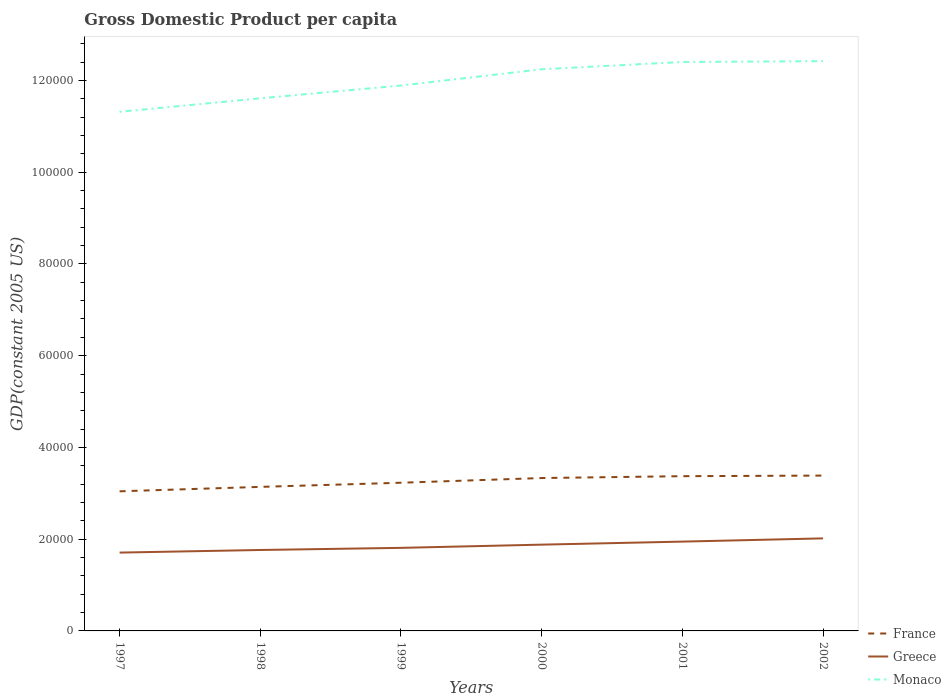How many different coloured lines are there?
Keep it short and to the point. 3. Is the number of lines equal to the number of legend labels?
Provide a succinct answer. Yes. Across all years, what is the maximum GDP per capita in Monaco?
Your response must be concise. 1.13e+05. What is the total GDP per capita in Greece in the graph?
Offer a very short reply. -1825.32. What is the difference between the highest and the second highest GDP per capita in Greece?
Provide a succinct answer. 3099.75. What is the difference between the highest and the lowest GDP per capita in Monaco?
Offer a terse response. 3. Is the GDP per capita in Monaco strictly greater than the GDP per capita in France over the years?
Give a very brief answer. No. How many lines are there?
Provide a succinct answer. 3. How many years are there in the graph?
Give a very brief answer. 6. What is the difference between two consecutive major ticks on the Y-axis?
Provide a short and direct response. 2.00e+04. Does the graph contain any zero values?
Keep it short and to the point. No. Where does the legend appear in the graph?
Provide a short and direct response. Bottom right. What is the title of the graph?
Provide a short and direct response. Gross Domestic Product per capita. What is the label or title of the X-axis?
Offer a very short reply. Years. What is the label or title of the Y-axis?
Your answer should be very brief. GDP(constant 2005 US). What is the GDP(constant 2005 US) in France in 1997?
Provide a succinct answer. 3.04e+04. What is the GDP(constant 2005 US) of Greece in 1997?
Your answer should be very brief. 1.71e+04. What is the GDP(constant 2005 US) of Monaco in 1997?
Your answer should be compact. 1.13e+05. What is the GDP(constant 2005 US) in France in 1998?
Provide a short and direct response. 3.14e+04. What is the GDP(constant 2005 US) of Greece in 1998?
Your answer should be very brief. 1.76e+04. What is the GDP(constant 2005 US) in Monaco in 1998?
Offer a very short reply. 1.16e+05. What is the GDP(constant 2005 US) of France in 1999?
Offer a very short reply. 3.23e+04. What is the GDP(constant 2005 US) of Greece in 1999?
Keep it short and to the point. 1.81e+04. What is the GDP(constant 2005 US) of Monaco in 1999?
Ensure brevity in your answer.  1.19e+05. What is the GDP(constant 2005 US) of France in 2000?
Provide a succinct answer. 3.33e+04. What is the GDP(constant 2005 US) in Greece in 2000?
Ensure brevity in your answer.  1.88e+04. What is the GDP(constant 2005 US) in Monaco in 2000?
Ensure brevity in your answer.  1.22e+05. What is the GDP(constant 2005 US) of France in 2001?
Provide a short and direct response. 3.37e+04. What is the GDP(constant 2005 US) of Greece in 2001?
Offer a very short reply. 1.95e+04. What is the GDP(constant 2005 US) in Monaco in 2001?
Your answer should be very brief. 1.24e+05. What is the GDP(constant 2005 US) of France in 2002?
Your answer should be compact. 3.39e+04. What is the GDP(constant 2005 US) of Greece in 2002?
Keep it short and to the point. 2.02e+04. What is the GDP(constant 2005 US) of Monaco in 2002?
Give a very brief answer. 1.24e+05. Across all years, what is the maximum GDP(constant 2005 US) in France?
Keep it short and to the point. 3.39e+04. Across all years, what is the maximum GDP(constant 2005 US) of Greece?
Offer a terse response. 2.02e+04. Across all years, what is the maximum GDP(constant 2005 US) in Monaco?
Your answer should be very brief. 1.24e+05. Across all years, what is the minimum GDP(constant 2005 US) of France?
Keep it short and to the point. 3.04e+04. Across all years, what is the minimum GDP(constant 2005 US) in Greece?
Offer a very short reply. 1.71e+04. Across all years, what is the minimum GDP(constant 2005 US) of Monaco?
Ensure brevity in your answer.  1.13e+05. What is the total GDP(constant 2005 US) in France in the graph?
Make the answer very short. 1.95e+05. What is the total GDP(constant 2005 US) in Greece in the graph?
Keep it short and to the point. 1.11e+05. What is the total GDP(constant 2005 US) in Monaco in the graph?
Provide a succinct answer. 7.19e+05. What is the difference between the GDP(constant 2005 US) in France in 1997 and that in 1998?
Give a very brief answer. -966.34. What is the difference between the GDP(constant 2005 US) of Greece in 1997 and that in 1998?
Your answer should be very brief. -569.5. What is the difference between the GDP(constant 2005 US) of Monaco in 1997 and that in 1998?
Provide a short and direct response. -2942.47. What is the difference between the GDP(constant 2005 US) in France in 1997 and that in 1999?
Your answer should be compact. -1869.59. What is the difference between the GDP(constant 2005 US) of Greece in 1997 and that in 1999?
Provide a short and direct response. -1031.95. What is the difference between the GDP(constant 2005 US) in Monaco in 1997 and that in 1999?
Your response must be concise. -5725.95. What is the difference between the GDP(constant 2005 US) in France in 1997 and that in 2000?
Offer a very short reply. -2892.38. What is the difference between the GDP(constant 2005 US) in Greece in 1997 and that in 2000?
Give a very brief answer. -1733.08. What is the difference between the GDP(constant 2005 US) in Monaco in 1997 and that in 2000?
Ensure brevity in your answer.  -9273.51. What is the difference between the GDP(constant 2005 US) of France in 1997 and that in 2001?
Your answer should be very brief. -3297.35. What is the difference between the GDP(constant 2005 US) of Greece in 1997 and that in 2001?
Your answer should be very brief. -2394.82. What is the difference between the GDP(constant 2005 US) in Monaco in 1997 and that in 2001?
Your response must be concise. -1.09e+04. What is the difference between the GDP(constant 2005 US) of France in 1997 and that in 2002?
Give a very brief answer. -3427.48. What is the difference between the GDP(constant 2005 US) of Greece in 1997 and that in 2002?
Keep it short and to the point. -3099.75. What is the difference between the GDP(constant 2005 US) in Monaco in 1997 and that in 2002?
Provide a succinct answer. -1.10e+04. What is the difference between the GDP(constant 2005 US) of France in 1998 and that in 1999?
Keep it short and to the point. -903.25. What is the difference between the GDP(constant 2005 US) in Greece in 1998 and that in 1999?
Provide a succinct answer. -462.45. What is the difference between the GDP(constant 2005 US) in Monaco in 1998 and that in 1999?
Your answer should be very brief. -2783.48. What is the difference between the GDP(constant 2005 US) in France in 1998 and that in 2000?
Give a very brief answer. -1926.04. What is the difference between the GDP(constant 2005 US) in Greece in 1998 and that in 2000?
Provide a short and direct response. -1163.58. What is the difference between the GDP(constant 2005 US) of Monaco in 1998 and that in 2000?
Provide a succinct answer. -6331.05. What is the difference between the GDP(constant 2005 US) in France in 1998 and that in 2001?
Offer a very short reply. -2331.01. What is the difference between the GDP(constant 2005 US) of Greece in 1998 and that in 2001?
Provide a succinct answer. -1825.32. What is the difference between the GDP(constant 2005 US) of Monaco in 1998 and that in 2001?
Give a very brief answer. -7915.61. What is the difference between the GDP(constant 2005 US) of France in 1998 and that in 2002?
Provide a short and direct response. -2461.14. What is the difference between the GDP(constant 2005 US) of Greece in 1998 and that in 2002?
Your answer should be very brief. -2530.25. What is the difference between the GDP(constant 2005 US) in Monaco in 1998 and that in 2002?
Provide a succinct answer. -8098.77. What is the difference between the GDP(constant 2005 US) in France in 1999 and that in 2000?
Give a very brief answer. -1022.79. What is the difference between the GDP(constant 2005 US) in Greece in 1999 and that in 2000?
Keep it short and to the point. -701.13. What is the difference between the GDP(constant 2005 US) in Monaco in 1999 and that in 2000?
Your answer should be compact. -3547.56. What is the difference between the GDP(constant 2005 US) in France in 1999 and that in 2001?
Offer a terse response. -1427.76. What is the difference between the GDP(constant 2005 US) in Greece in 1999 and that in 2001?
Offer a terse response. -1362.88. What is the difference between the GDP(constant 2005 US) of Monaco in 1999 and that in 2001?
Give a very brief answer. -5132.13. What is the difference between the GDP(constant 2005 US) of France in 1999 and that in 2002?
Provide a short and direct response. -1557.89. What is the difference between the GDP(constant 2005 US) of Greece in 1999 and that in 2002?
Keep it short and to the point. -2067.8. What is the difference between the GDP(constant 2005 US) of Monaco in 1999 and that in 2002?
Provide a succinct answer. -5315.29. What is the difference between the GDP(constant 2005 US) in France in 2000 and that in 2001?
Give a very brief answer. -404.97. What is the difference between the GDP(constant 2005 US) of Greece in 2000 and that in 2001?
Your answer should be very brief. -661.74. What is the difference between the GDP(constant 2005 US) in Monaco in 2000 and that in 2001?
Provide a succinct answer. -1584.56. What is the difference between the GDP(constant 2005 US) of France in 2000 and that in 2002?
Keep it short and to the point. -535.09. What is the difference between the GDP(constant 2005 US) of Greece in 2000 and that in 2002?
Make the answer very short. -1366.67. What is the difference between the GDP(constant 2005 US) in Monaco in 2000 and that in 2002?
Provide a succinct answer. -1767.72. What is the difference between the GDP(constant 2005 US) in France in 2001 and that in 2002?
Provide a short and direct response. -130.13. What is the difference between the GDP(constant 2005 US) in Greece in 2001 and that in 2002?
Keep it short and to the point. -704.93. What is the difference between the GDP(constant 2005 US) in Monaco in 2001 and that in 2002?
Your answer should be compact. -183.16. What is the difference between the GDP(constant 2005 US) of France in 1997 and the GDP(constant 2005 US) of Greece in 1998?
Make the answer very short. 1.28e+04. What is the difference between the GDP(constant 2005 US) in France in 1997 and the GDP(constant 2005 US) in Monaco in 1998?
Offer a terse response. -8.57e+04. What is the difference between the GDP(constant 2005 US) of Greece in 1997 and the GDP(constant 2005 US) of Monaco in 1998?
Give a very brief answer. -9.90e+04. What is the difference between the GDP(constant 2005 US) in France in 1997 and the GDP(constant 2005 US) in Greece in 1999?
Provide a succinct answer. 1.23e+04. What is the difference between the GDP(constant 2005 US) of France in 1997 and the GDP(constant 2005 US) of Monaco in 1999?
Your answer should be very brief. -8.85e+04. What is the difference between the GDP(constant 2005 US) of Greece in 1997 and the GDP(constant 2005 US) of Monaco in 1999?
Keep it short and to the point. -1.02e+05. What is the difference between the GDP(constant 2005 US) in France in 1997 and the GDP(constant 2005 US) in Greece in 2000?
Your answer should be compact. 1.16e+04. What is the difference between the GDP(constant 2005 US) of France in 1997 and the GDP(constant 2005 US) of Monaco in 2000?
Make the answer very short. -9.20e+04. What is the difference between the GDP(constant 2005 US) of Greece in 1997 and the GDP(constant 2005 US) of Monaco in 2000?
Your response must be concise. -1.05e+05. What is the difference between the GDP(constant 2005 US) of France in 1997 and the GDP(constant 2005 US) of Greece in 2001?
Offer a terse response. 1.10e+04. What is the difference between the GDP(constant 2005 US) in France in 1997 and the GDP(constant 2005 US) in Monaco in 2001?
Provide a short and direct response. -9.36e+04. What is the difference between the GDP(constant 2005 US) of Greece in 1997 and the GDP(constant 2005 US) of Monaco in 2001?
Ensure brevity in your answer.  -1.07e+05. What is the difference between the GDP(constant 2005 US) of France in 1997 and the GDP(constant 2005 US) of Greece in 2002?
Provide a succinct answer. 1.03e+04. What is the difference between the GDP(constant 2005 US) of France in 1997 and the GDP(constant 2005 US) of Monaco in 2002?
Provide a short and direct response. -9.38e+04. What is the difference between the GDP(constant 2005 US) in Greece in 1997 and the GDP(constant 2005 US) in Monaco in 2002?
Provide a short and direct response. -1.07e+05. What is the difference between the GDP(constant 2005 US) of France in 1998 and the GDP(constant 2005 US) of Greece in 1999?
Keep it short and to the point. 1.33e+04. What is the difference between the GDP(constant 2005 US) of France in 1998 and the GDP(constant 2005 US) of Monaco in 1999?
Make the answer very short. -8.75e+04. What is the difference between the GDP(constant 2005 US) in Greece in 1998 and the GDP(constant 2005 US) in Monaco in 1999?
Make the answer very short. -1.01e+05. What is the difference between the GDP(constant 2005 US) in France in 1998 and the GDP(constant 2005 US) in Greece in 2000?
Provide a succinct answer. 1.26e+04. What is the difference between the GDP(constant 2005 US) in France in 1998 and the GDP(constant 2005 US) in Monaco in 2000?
Offer a terse response. -9.10e+04. What is the difference between the GDP(constant 2005 US) in Greece in 1998 and the GDP(constant 2005 US) in Monaco in 2000?
Offer a very short reply. -1.05e+05. What is the difference between the GDP(constant 2005 US) of France in 1998 and the GDP(constant 2005 US) of Greece in 2001?
Give a very brief answer. 1.19e+04. What is the difference between the GDP(constant 2005 US) of France in 1998 and the GDP(constant 2005 US) of Monaco in 2001?
Provide a succinct answer. -9.26e+04. What is the difference between the GDP(constant 2005 US) in Greece in 1998 and the GDP(constant 2005 US) in Monaco in 2001?
Offer a very short reply. -1.06e+05. What is the difference between the GDP(constant 2005 US) in France in 1998 and the GDP(constant 2005 US) in Greece in 2002?
Ensure brevity in your answer.  1.12e+04. What is the difference between the GDP(constant 2005 US) in France in 1998 and the GDP(constant 2005 US) in Monaco in 2002?
Offer a terse response. -9.28e+04. What is the difference between the GDP(constant 2005 US) of Greece in 1998 and the GDP(constant 2005 US) of Monaco in 2002?
Provide a succinct answer. -1.07e+05. What is the difference between the GDP(constant 2005 US) of France in 1999 and the GDP(constant 2005 US) of Greece in 2000?
Keep it short and to the point. 1.35e+04. What is the difference between the GDP(constant 2005 US) of France in 1999 and the GDP(constant 2005 US) of Monaco in 2000?
Ensure brevity in your answer.  -9.01e+04. What is the difference between the GDP(constant 2005 US) of Greece in 1999 and the GDP(constant 2005 US) of Monaco in 2000?
Your answer should be very brief. -1.04e+05. What is the difference between the GDP(constant 2005 US) in France in 1999 and the GDP(constant 2005 US) in Greece in 2001?
Your response must be concise. 1.28e+04. What is the difference between the GDP(constant 2005 US) in France in 1999 and the GDP(constant 2005 US) in Monaco in 2001?
Ensure brevity in your answer.  -9.17e+04. What is the difference between the GDP(constant 2005 US) of Greece in 1999 and the GDP(constant 2005 US) of Monaco in 2001?
Offer a very short reply. -1.06e+05. What is the difference between the GDP(constant 2005 US) of France in 1999 and the GDP(constant 2005 US) of Greece in 2002?
Keep it short and to the point. 1.21e+04. What is the difference between the GDP(constant 2005 US) in France in 1999 and the GDP(constant 2005 US) in Monaco in 2002?
Provide a short and direct response. -9.19e+04. What is the difference between the GDP(constant 2005 US) of Greece in 1999 and the GDP(constant 2005 US) of Monaco in 2002?
Provide a short and direct response. -1.06e+05. What is the difference between the GDP(constant 2005 US) of France in 2000 and the GDP(constant 2005 US) of Greece in 2001?
Give a very brief answer. 1.39e+04. What is the difference between the GDP(constant 2005 US) of France in 2000 and the GDP(constant 2005 US) of Monaco in 2001?
Give a very brief answer. -9.07e+04. What is the difference between the GDP(constant 2005 US) of Greece in 2000 and the GDP(constant 2005 US) of Monaco in 2001?
Provide a short and direct response. -1.05e+05. What is the difference between the GDP(constant 2005 US) in France in 2000 and the GDP(constant 2005 US) in Greece in 2002?
Offer a terse response. 1.32e+04. What is the difference between the GDP(constant 2005 US) in France in 2000 and the GDP(constant 2005 US) in Monaco in 2002?
Give a very brief answer. -9.09e+04. What is the difference between the GDP(constant 2005 US) in Greece in 2000 and the GDP(constant 2005 US) in Monaco in 2002?
Provide a succinct answer. -1.05e+05. What is the difference between the GDP(constant 2005 US) of France in 2001 and the GDP(constant 2005 US) of Greece in 2002?
Your answer should be very brief. 1.36e+04. What is the difference between the GDP(constant 2005 US) of France in 2001 and the GDP(constant 2005 US) of Monaco in 2002?
Provide a short and direct response. -9.05e+04. What is the difference between the GDP(constant 2005 US) of Greece in 2001 and the GDP(constant 2005 US) of Monaco in 2002?
Offer a very short reply. -1.05e+05. What is the average GDP(constant 2005 US) of France per year?
Offer a very short reply. 3.25e+04. What is the average GDP(constant 2005 US) in Greece per year?
Offer a terse response. 1.85e+04. What is the average GDP(constant 2005 US) of Monaco per year?
Your response must be concise. 1.20e+05. In the year 1997, what is the difference between the GDP(constant 2005 US) of France and GDP(constant 2005 US) of Greece?
Your response must be concise. 1.34e+04. In the year 1997, what is the difference between the GDP(constant 2005 US) of France and GDP(constant 2005 US) of Monaco?
Provide a succinct answer. -8.27e+04. In the year 1997, what is the difference between the GDP(constant 2005 US) in Greece and GDP(constant 2005 US) in Monaco?
Your answer should be very brief. -9.61e+04. In the year 1998, what is the difference between the GDP(constant 2005 US) in France and GDP(constant 2005 US) in Greece?
Provide a succinct answer. 1.38e+04. In the year 1998, what is the difference between the GDP(constant 2005 US) of France and GDP(constant 2005 US) of Monaco?
Your response must be concise. -8.47e+04. In the year 1998, what is the difference between the GDP(constant 2005 US) in Greece and GDP(constant 2005 US) in Monaco?
Your answer should be compact. -9.85e+04. In the year 1999, what is the difference between the GDP(constant 2005 US) in France and GDP(constant 2005 US) in Greece?
Your answer should be compact. 1.42e+04. In the year 1999, what is the difference between the GDP(constant 2005 US) in France and GDP(constant 2005 US) in Monaco?
Ensure brevity in your answer.  -8.66e+04. In the year 1999, what is the difference between the GDP(constant 2005 US) of Greece and GDP(constant 2005 US) of Monaco?
Your answer should be compact. -1.01e+05. In the year 2000, what is the difference between the GDP(constant 2005 US) in France and GDP(constant 2005 US) in Greece?
Ensure brevity in your answer.  1.45e+04. In the year 2000, what is the difference between the GDP(constant 2005 US) in France and GDP(constant 2005 US) in Monaco?
Keep it short and to the point. -8.91e+04. In the year 2000, what is the difference between the GDP(constant 2005 US) of Greece and GDP(constant 2005 US) of Monaco?
Provide a short and direct response. -1.04e+05. In the year 2001, what is the difference between the GDP(constant 2005 US) of France and GDP(constant 2005 US) of Greece?
Give a very brief answer. 1.43e+04. In the year 2001, what is the difference between the GDP(constant 2005 US) of France and GDP(constant 2005 US) of Monaco?
Keep it short and to the point. -9.03e+04. In the year 2001, what is the difference between the GDP(constant 2005 US) of Greece and GDP(constant 2005 US) of Monaco?
Offer a very short reply. -1.05e+05. In the year 2002, what is the difference between the GDP(constant 2005 US) in France and GDP(constant 2005 US) in Greece?
Provide a short and direct response. 1.37e+04. In the year 2002, what is the difference between the GDP(constant 2005 US) in France and GDP(constant 2005 US) in Monaco?
Keep it short and to the point. -9.03e+04. In the year 2002, what is the difference between the GDP(constant 2005 US) of Greece and GDP(constant 2005 US) of Monaco?
Make the answer very short. -1.04e+05. What is the ratio of the GDP(constant 2005 US) in France in 1997 to that in 1998?
Give a very brief answer. 0.97. What is the ratio of the GDP(constant 2005 US) in Greece in 1997 to that in 1998?
Keep it short and to the point. 0.97. What is the ratio of the GDP(constant 2005 US) of Monaco in 1997 to that in 1998?
Ensure brevity in your answer.  0.97. What is the ratio of the GDP(constant 2005 US) of France in 1997 to that in 1999?
Offer a very short reply. 0.94. What is the ratio of the GDP(constant 2005 US) in Greece in 1997 to that in 1999?
Offer a very short reply. 0.94. What is the ratio of the GDP(constant 2005 US) in Monaco in 1997 to that in 1999?
Offer a very short reply. 0.95. What is the ratio of the GDP(constant 2005 US) in France in 1997 to that in 2000?
Provide a short and direct response. 0.91. What is the ratio of the GDP(constant 2005 US) in Greece in 1997 to that in 2000?
Your answer should be compact. 0.91. What is the ratio of the GDP(constant 2005 US) in Monaco in 1997 to that in 2000?
Make the answer very short. 0.92. What is the ratio of the GDP(constant 2005 US) of France in 1997 to that in 2001?
Offer a terse response. 0.9. What is the ratio of the GDP(constant 2005 US) in Greece in 1997 to that in 2001?
Your answer should be very brief. 0.88. What is the ratio of the GDP(constant 2005 US) of Monaco in 1997 to that in 2001?
Make the answer very short. 0.91. What is the ratio of the GDP(constant 2005 US) of France in 1997 to that in 2002?
Provide a succinct answer. 0.9. What is the ratio of the GDP(constant 2005 US) of Greece in 1997 to that in 2002?
Keep it short and to the point. 0.85. What is the ratio of the GDP(constant 2005 US) of Monaco in 1997 to that in 2002?
Offer a terse response. 0.91. What is the ratio of the GDP(constant 2005 US) of Greece in 1998 to that in 1999?
Your answer should be compact. 0.97. What is the ratio of the GDP(constant 2005 US) in Monaco in 1998 to that in 1999?
Make the answer very short. 0.98. What is the ratio of the GDP(constant 2005 US) in France in 1998 to that in 2000?
Offer a terse response. 0.94. What is the ratio of the GDP(constant 2005 US) in Greece in 1998 to that in 2000?
Make the answer very short. 0.94. What is the ratio of the GDP(constant 2005 US) of Monaco in 1998 to that in 2000?
Your response must be concise. 0.95. What is the ratio of the GDP(constant 2005 US) in France in 1998 to that in 2001?
Offer a very short reply. 0.93. What is the ratio of the GDP(constant 2005 US) of Greece in 1998 to that in 2001?
Your response must be concise. 0.91. What is the ratio of the GDP(constant 2005 US) in Monaco in 1998 to that in 2001?
Ensure brevity in your answer.  0.94. What is the ratio of the GDP(constant 2005 US) in France in 1998 to that in 2002?
Give a very brief answer. 0.93. What is the ratio of the GDP(constant 2005 US) in Greece in 1998 to that in 2002?
Give a very brief answer. 0.87. What is the ratio of the GDP(constant 2005 US) in Monaco in 1998 to that in 2002?
Offer a very short reply. 0.93. What is the ratio of the GDP(constant 2005 US) in France in 1999 to that in 2000?
Ensure brevity in your answer.  0.97. What is the ratio of the GDP(constant 2005 US) of Greece in 1999 to that in 2000?
Your answer should be compact. 0.96. What is the ratio of the GDP(constant 2005 US) in France in 1999 to that in 2001?
Provide a succinct answer. 0.96. What is the ratio of the GDP(constant 2005 US) in Greece in 1999 to that in 2001?
Provide a succinct answer. 0.93. What is the ratio of the GDP(constant 2005 US) in Monaco in 1999 to that in 2001?
Keep it short and to the point. 0.96. What is the ratio of the GDP(constant 2005 US) in France in 1999 to that in 2002?
Make the answer very short. 0.95. What is the ratio of the GDP(constant 2005 US) in Greece in 1999 to that in 2002?
Keep it short and to the point. 0.9. What is the ratio of the GDP(constant 2005 US) in Monaco in 1999 to that in 2002?
Your response must be concise. 0.96. What is the ratio of the GDP(constant 2005 US) of Monaco in 2000 to that in 2001?
Offer a very short reply. 0.99. What is the ratio of the GDP(constant 2005 US) of France in 2000 to that in 2002?
Offer a terse response. 0.98. What is the ratio of the GDP(constant 2005 US) in Greece in 2000 to that in 2002?
Provide a succinct answer. 0.93. What is the ratio of the GDP(constant 2005 US) of Monaco in 2000 to that in 2002?
Provide a succinct answer. 0.99. What is the ratio of the GDP(constant 2005 US) of Greece in 2001 to that in 2002?
Your answer should be very brief. 0.97. What is the ratio of the GDP(constant 2005 US) in Monaco in 2001 to that in 2002?
Keep it short and to the point. 1. What is the difference between the highest and the second highest GDP(constant 2005 US) of France?
Your response must be concise. 130.13. What is the difference between the highest and the second highest GDP(constant 2005 US) of Greece?
Keep it short and to the point. 704.93. What is the difference between the highest and the second highest GDP(constant 2005 US) of Monaco?
Provide a short and direct response. 183.16. What is the difference between the highest and the lowest GDP(constant 2005 US) of France?
Offer a terse response. 3427.48. What is the difference between the highest and the lowest GDP(constant 2005 US) of Greece?
Provide a succinct answer. 3099.75. What is the difference between the highest and the lowest GDP(constant 2005 US) of Monaco?
Your answer should be very brief. 1.10e+04. 